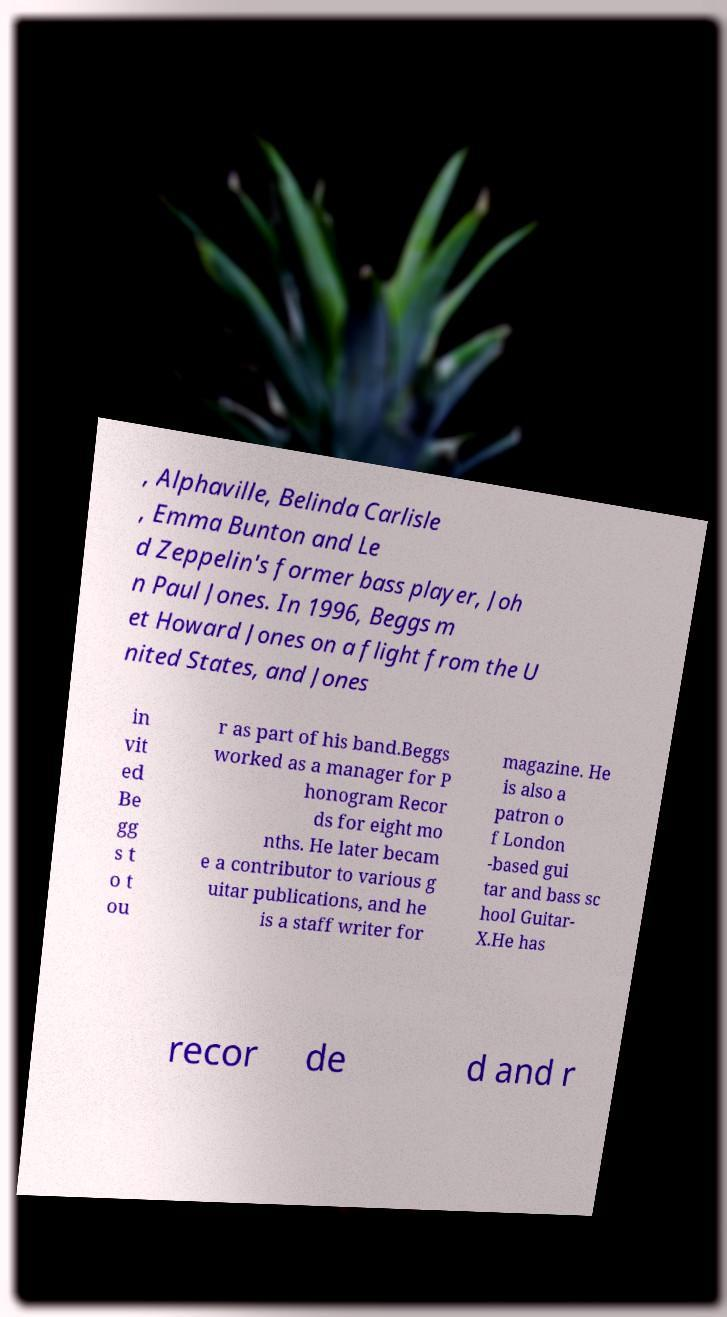Could you assist in decoding the text presented in this image and type it out clearly? , Alphaville, Belinda Carlisle , Emma Bunton and Le d Zeppelin's former bass player, Joh n Paul Jones. In 1996, Beggs m et Howard Jones on a flight from the U nited States, and Jones in vit ed Be gg s t o t ou r as part of his band.Beggs worked as a manager for P honogram Recor ds for eight mo nths. He later becam e a contributor to various g uitar publications, and he is a staff writer for magazine. He is also a patron o f London -based gui tar and bass sc hool Guitar- X.He has recor de d and r 